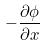Convert formula to latex. <formula><loc_0><loc_0><loc_500><loc_500>- \frac { \partial \phi } { \partial x }</formula> 